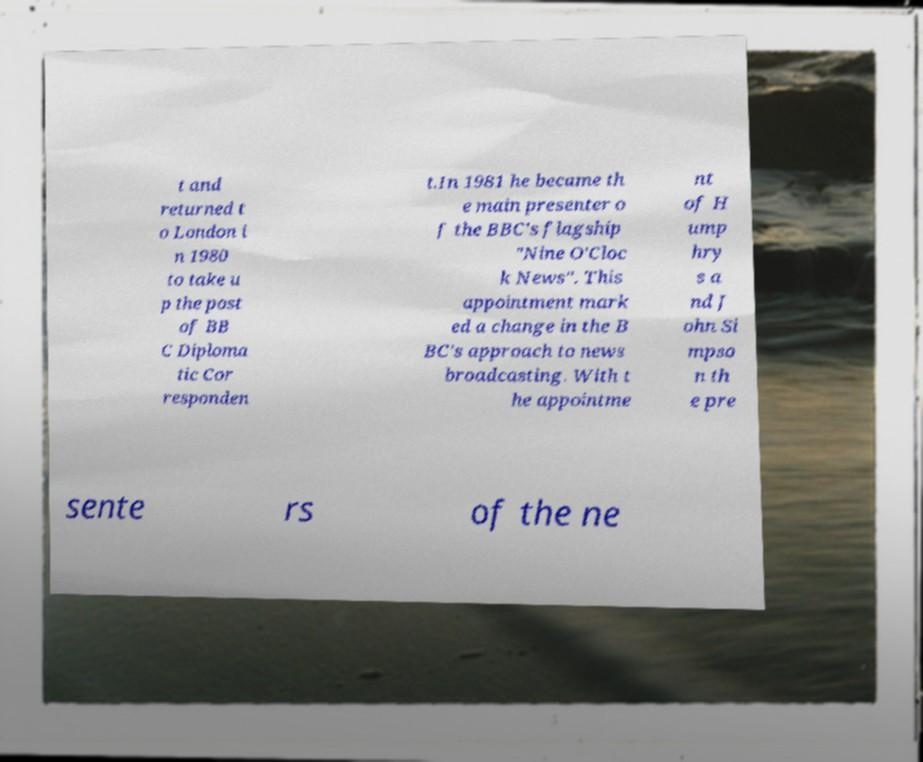Can you accurately transcribe the text from the provided image for me? t and returned t o London i n 1980 to take u p the post of BB C Diploma tic Cor responden t.In 1981 he became th e main presenter o f the BBC's flagship "Nine O'Cloc k News". This appointment mark ed a change in the B BC's approach to news broadcasting. With t he appointme nt of H ump hry s a nd J ohn Si mpso n th e pre sente rs of the ne 